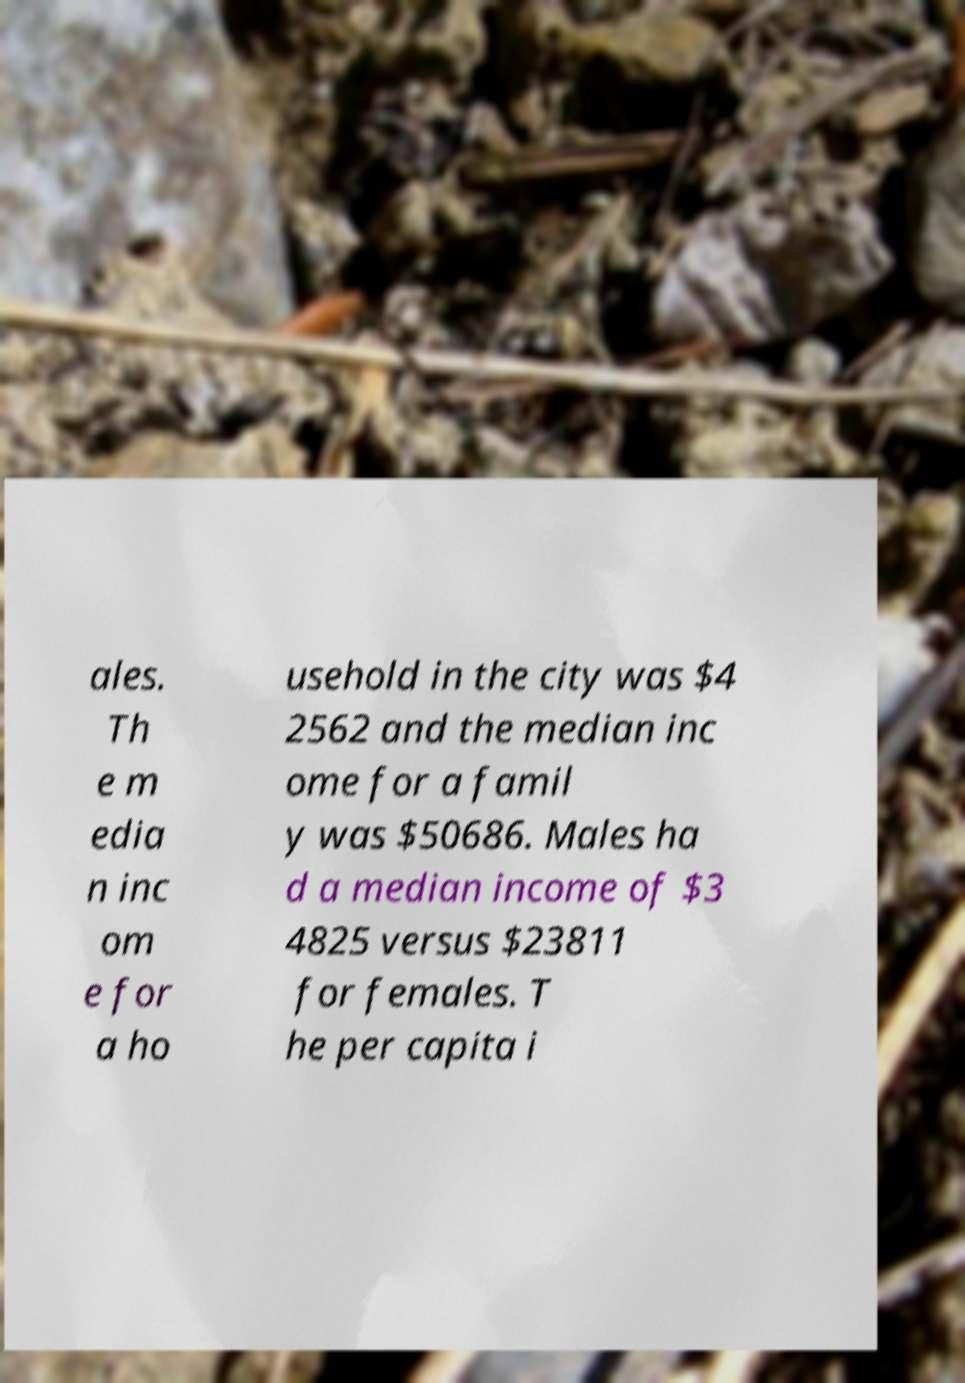Could you assist in decoding the text presented in this image and type it out clearly? ales. Th e m edia n inc om e for a ho usehold in the city was $4 2562 and the median inc ome for a famil y was $50686. Males ha d a median income of $3 4825 versus $23811 for females. T he per capita i 